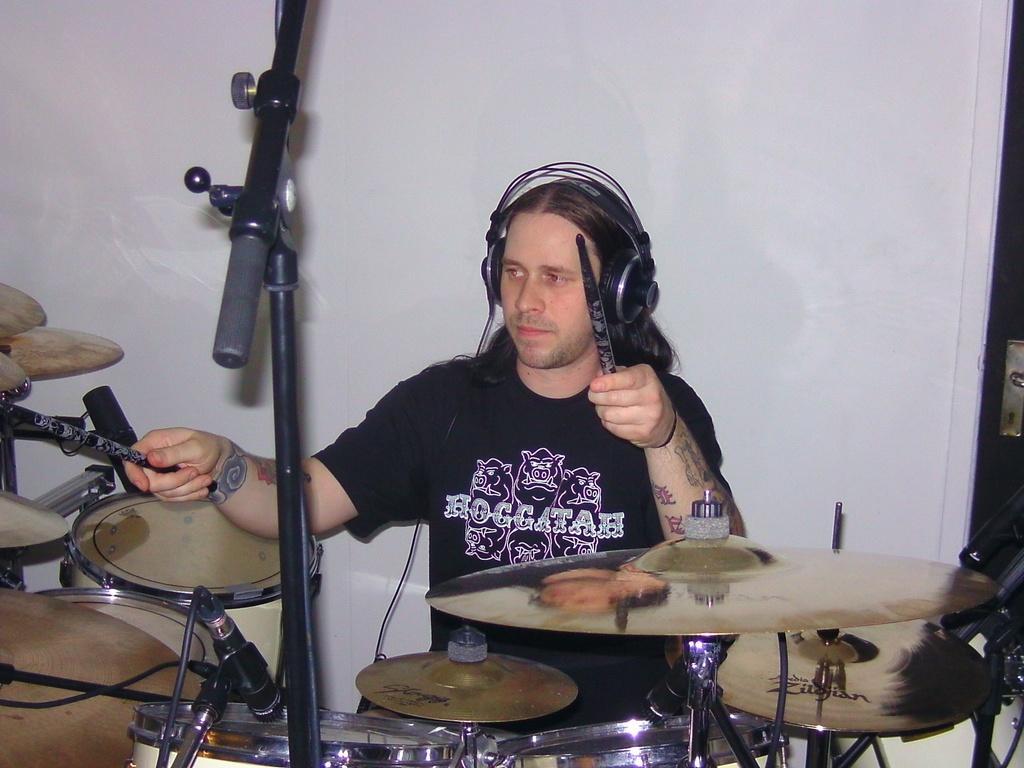Can you describe this image briefly? This is the man standing and holding sticks. He wore a T-shirt and a headset. I think he is playing the drums. This is a mile, which is attached to the mike stand. I think this is a hi-hat instrument. This looks like a wall, which is white in color. On the right corner of the image, I think this is a door with a door handle. 